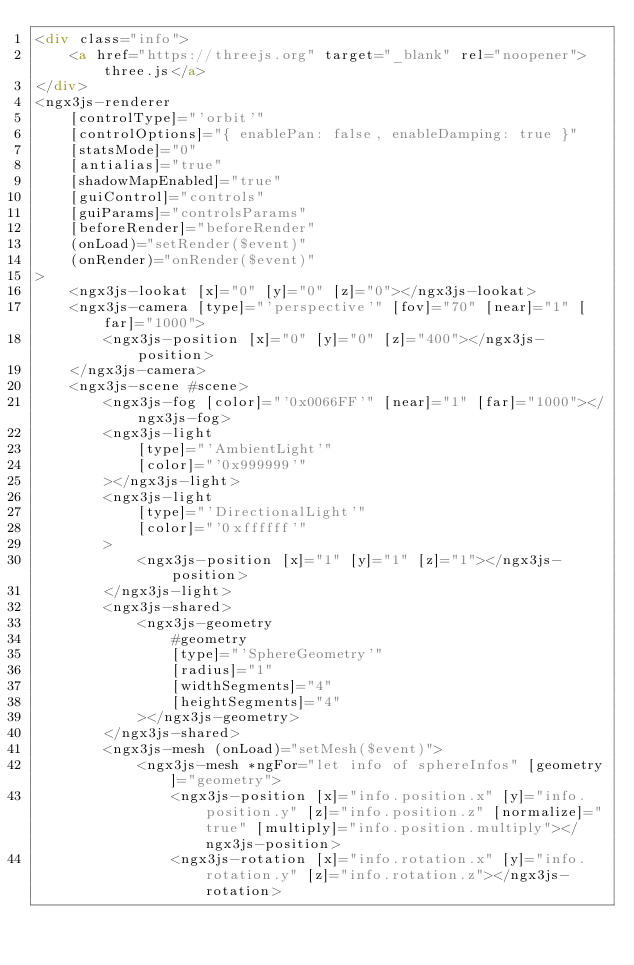Convert code to text. <code><loc_0><loc_0><loc_500><loc_500><_HTML_><div class="info">
	<a href="https://threejs.org" target="_blank" rel="noopener">three.js</a>
</div>
<ngx3js-renderer
	[controlType]="'orbit'"
	[controlOptions]="{ enablePan: false, enableDamping: true }"
	[statsMode]="0"
	[antialias]="true"
	[shadowMapEnabled]="true"
	[guiControl]="controls"
	[guiParams]="controlsParams"
	[beforeRender]="beforeRender"
	(onLoad)="setRender($event)"
	(onRender)="onRender($event)"
>
	<ngx3js-lookat [x]="0" [y]="0" [z]="0"></ngx3js-lookat>
	<ngx3js-camera [type]="'perspective'" [fov]="70" [near]="1" [far]="1000">
		<ngx3js-position [x]="0" [y]="0" [z]="400"></ngx3js-position>
	</ngx3js-camera>
	<ngx3js-scene #scene>
		<ngx3js-fog [color]="'0x0066FF'" [near]="1" [far]="1000"></ngx3js-fog>
		<ngx3js-light
			[type]="'AmbientLight'"
			[color]="'0x999999'"
		></ngx3js-light>
		<ngx3js-light
			[type]="'DirectionalLight'"
			[color]="'0xffffff'"
		>
			<ngx3js-position [x]="1" [y]="1" [z]="1"></ngx3js-position>
		</ngx3js-light>
		<ngx3js-shared>
			<ngx3js-geometry
				#geometry
				[type]="'SphereGeometry'"
				[radius]="1"
				[widthSegments]="4"
				[heightSegments]="4"
			></ngx3js-geometry>
		</ngx3js-shared>
		<ngx3js-mesh (onLoad)="setMesh($event)">
			<ngx3js-mesh *ngFor="let info of sphereInfos" [geometry]="geometry">
				<ngx3js-position [x]="info.position.x" [y]="info.position.y" [z]="info.position.z" [normalize]="true" [multiply]="info.position.multiply"></ngx3js-position>
				<ngx3js-rotation [x]="info.rotation.x" [y]="info.rotation.y" [z]="info.rotation.z"></ngx3js-rotation></code> 